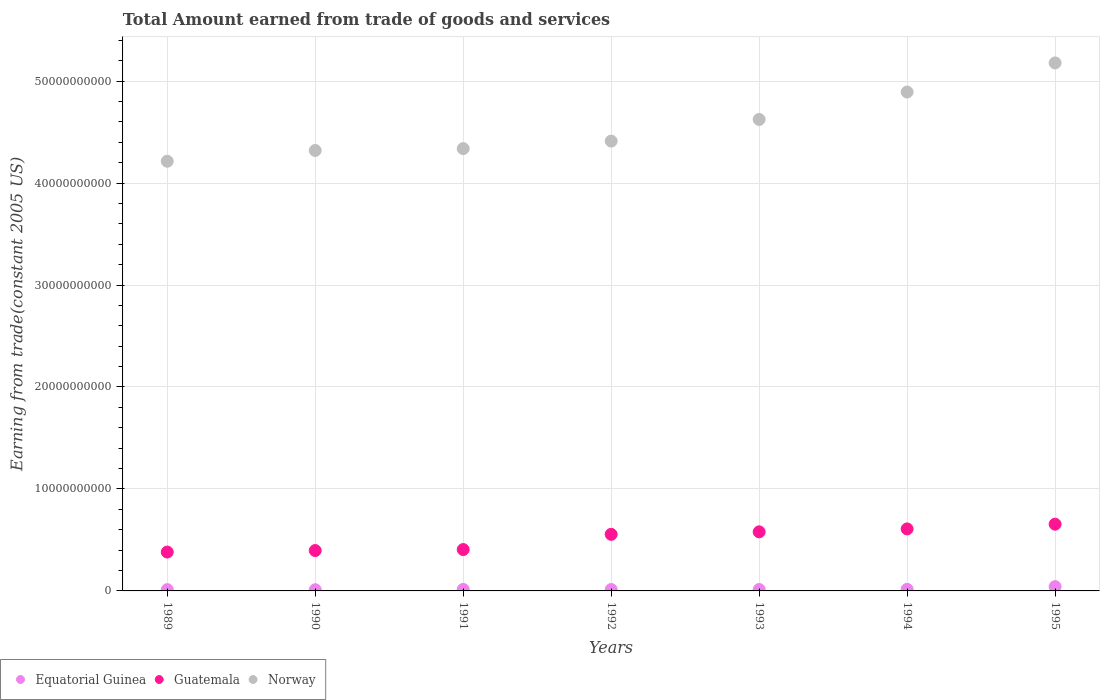What is the total amount earned by trading goods and services in Norway in 1989?
Keep it short and to the point. 4.21e+1. Across all years, what is the maximum total amount earned by trading goods and services in Norway?
Your answer should be very brief. 5.18e+1. Across all years, what is the minimum total amount earned by trading goods and services in Norway?
Keep it short and to the point. 4.21e+1. In which year was the total amount earned by trading goods and services in Equatorial Guinea minimum?
Your answer should be compact. 1990. What is the total total amount earned by trading goods and services in Equatorial Guinea in the graph?
Make the answer very short. 1.23e+09. What is the difference between the total amount earned by trading goods and services in Norway in 1991 and that in 1994?
Offer a terse response. -5.55e+09. What is the difference between the total amount earned by trading goods and services in Guatemala in 1992 and the total amount earned by trading goods and services in Equatorial Guinea in 1994?
Your answer should be very brief. 5.39e+09. What is the average total amount earned by trading goods and services in Norway per year?
Provide a short and direct response. 4.57e+1. In the year 1993, what is the difference between the total amount earned by trading goods and services in Guatemala and total amount earned by trading goods and services in Equatorial Guinea?
Offer a terse response. 5.66e+09. What is the ratio of the total amount earned by trading goods and services in Equatorial Guinea in 1991 to that in 1993?
Provide a short and direct response. 1.08. Is the difference between the total amount earned by trading goods and services in Guatemala in 1989 and 1991 greater than the difference between the total amount earned by trading goods and services in Equatorial Guinea in 1989 and 1991?
Your answer should be very brief. No. What is the difference between the highest and the second highest total amount earned by trading goods and services in Guatemala?
Your answer should be very brief. 4.62e+08. What is the difference between the highest and the lowest total amount earned by trading goods and services in Equatorial Guinea?
Provide a succinct answer. 3.05e+08. Is the sum of the total amount earned by trading goods and services in Norway in 1994 and 1995 greater than the maximum total amount earned by trading goods and services in Guatemala across all years?
Provide a short and direct response. Yes. Does the total amount earned by trading goods and services in Norway monotonically increase over the years?
Give a very brief answer. Yes. What is the difference between two consecutive major ticks on the Y-axis?
Provide a succinct answer. 1.00e+1. Does the graph contain any zero values?
Give a very brief answer. No. Does the graph contain grids?
Give a very brief answer. Yes. How are the legend labels stacked?
Your answer should be compact. Horizontal. What is the title of the graph?
Your answer should be compact. Total Amount earned from trade of goods and services. Does "Central Europe" appear as one of the legend labels in the graph?
Offer a terse response. No. What is the label or title of the Y-axis?
Offer a terse response. Earning from trade(constant 2005 US). What is the Earning from trade(constant 2005 US) of Equatorial Guinea in 1989?
Keep it short and to the point. 1.25e+08. What is the Earning from trade(constant 2005 US) in Guatemala in 1989?
Provide a succinct answer. 3.81e+09. What is the Earning from trade(constant 2005 US) of Norway in 1989?
Offer a very short reply. 4.21e+1. What is the Earning from trade(constant 2005 US) of Equatorial Guinea in 1990?
Give a very brief answer. 1.16e+08. What is the Earning from trade(constant 2005 US) in Guatemala in 1990?
Provide a short and direct response. 3.96e+09. What is the Earning from trade(constant 2005 US) of Norway in 1990?
Offer a terse response. 4.32e+1. What is the Earning from trade(constant 2005 US) in Equatorial Guinea in 1991?
Provide a short and direct response. 1.46e+08. What is the Earning from trade(constant 2005 US) of Guatemala in 1991?
Give a very brief answer. 4.06e+09. What is the Earning from trade(constant 2005 US) of Norway in 1991?
Your answer should be compact. 4.34e+1. What is the Earning from trade(constant 2005 US) of Equatorial Guinea in 1992?
Give a very brief answer. 1.35e+08. What is the Earning from trade(constant 2005 US) in Guatemala in 1992?
Ensure brevity in your answer.  5.55e+09. What is the Earning from trade(constant 2005 US) of Norway in 1992?
Give a very brief answer. 4.41e+1. What is the Earning from trade(constant 2005 US) in Equatorial Guinea in 1993?
Your answer should be compact. 1.35e+08. What is the Earning from trade(constant 2005 US) in Guatemala in 1993?
Provide a short and direct response. 5.79e+09. What is the Earning from trade(constant 2005 US) of Norway in 1993?
Your response must be concise. 4.62e+1. What is the Earning from trade(constant 2005 US) in Equatorial Guinea in 1994?
Keep it short and to the point. 1.54e+08. What is the Earning from trade(constant 2005 US) of Guatemala in 1994?
Ensure brevity in your answer.  6.08e+09. What is the Earning from trade(constant 2005 US) of Norway in 1994?
Your response must be concise. 4.89e+1. What is the Earning from trade(constant 2005 US) of Equatorial Guinea in 1995?
Your response must be concise. 4.21e+08. What is the Earning from trade(constant 2005 US) in Guatemala in 1995?
Your answer should be compact. 6.54e+09. What is the Earning from trade(constant 2005 US) in Norway in 1995?
Your answer should be very brief. 5.18e+1. Across all years, what is the maximum Earning from trade(constant 2005 US) in Equatorial Guinea?
Your answer should be very brief. 4.21e+08. Across all years, what is the maximum Earning from trade(constant 2005 US) in Guatemala?
Provide a short and direct response. 6.54e+09. Across all years, what is the maximum Earning from trade(constant 2005 US) of Norway?
Your response must be concise. 5.18e+1. Across all years, what is the minimum Earning from trade(constant 2005 US) of Equatorial Guinea?
Provide a succinct answer. 1.16e+08. Across all years, what is the minimum Earning from trade(constant 2005 US) in Guatemala?
Your answer should be very brief. 3.81e+09. Across all years, what is the minimum Earning from trade(constant 2005 US) in Norway?
Your answer should be very brief. 4.21e+1. What is the total Earning from trade(constant 2005 US) in Equatorial Guinea in the graph?
Your answer should be very brief. 1.23e+09. What is the total Earning from trade(constant 2005 US) of Guatemala in the graph?
Offer a terse response. 3.58e+1. What is the total Earning from trade(constant 2005 US) of Norway in the graph?
Give a very brief answer. 3.20e+11. What is the difference between the Earning from trade(constant 2005 US) of Equatorial Guinea in 1989 and that in 1990?
Your response must be concise. 9.69e+06. What is the difference between the Earning from trade(constant 2005 US) of Guatemala in 1989 and that in 1990?
Offer a very short reply. -1.48e+08. What is the difference between the Earning from trade(constant 2005 US) in Norway in 1989 and that in 1990?
Provide a short and direct response. -1.06e+09. What is the difference between the Earning from trade(constant 2005 US) of Equatorial Guinea in 1989 and that in 1991?
Your answer should be very brief. -2.10e+07. What is the difference between the Earning from trade(constant 2005 US) in Guatemala in 1989 and that in 1991?
Your response must be concise. -2.46e+08. What is the difference between the Earning from trade(constant 2005 US) of Norway in 1989 and that in 1991?
Keep it short and to the point. -1.24e+09. What is the difference between the Earning from trade(constant 2005 US) of Equatorial Guinea in 1989 and that in 1992?
Provide a succinct answer. -9.87e+06. What is the difference between the Earning from trade(constant 2005 US) in Guatemala in 1989 and that in 1992?
Your answer should be compact. -1.74e+09. What is the difference between the Earning from trade(constant 2005 US) of Norway in 1989 and that in 1992?
Your answer should be compact. -1.98e+09. What is the difference between the Earning from trade(constant 2005 US) of Equatorial Guinea in 1989 and that in 1993?
Your response must be concise. -1.01e+07. What is the difference between the Earning from trade(constant 2005 US) in Guatemala in 1989 and that in 1993?
Offer a very short reply. -1.98e+09. What is the difference between the Earning from trade(constant 2005 US) in Norway in 1989 and that in 1993?
Ensure brevity in your answer.  -4.10e+09. What is the difference between the Earning from trade(constant 2005 US) in Equatorial Guinea in 1989 and that in 1994?
Provide a short and direct response. -2.91e+07. What is the difference between the Earning from trade(constant 2005 US) of Guatemala in 1989 and that in 1994?
Provide a short and direct response. -2.27e+09. What is the difference between the Earning from trade(constant 2005 US) of Norway in 1989 and that in 1994?
Provide a succinct answer. -6.79e+09. What is the difference between the Earning from trade(constant 2005 US) of Equatorial Guinea in 1989 and that in 1995?
Provide a short and direct response. -2.95e+08. What is the difference between the Earning from trade(constant 2005 US) of Guatemala in 1989 and that in 1995?
Your answer should be compact. -2.73e+09. What is the difference between the Earning from trade(constant 2005 US) in Norway in 1989 and that in 1995?
Your answer should be compact. -9.64e+09. What is the difference between the Earning from trade(constant 2005 US) in Equatorial Guinea in 1990 and that in 1991?
Offer a very short reply. -3.07e+07. What is the difference between the Earning from trade(constant 2005 US) of Guatemala in 1990 and that in 1991?
Offer a terse response. -9.72e+07. What is the difference between the Earning from trade(constant 2005 US) of Norway in 1990 and that in 1991?
Give a very brief answer. -1.83e+08. What is the difference between the Earning from trade(constant 2005 US) in Equatorial Guinea in 1990 and that in 1992?
Ensure brevity in your answer.  -1.96e+07. What is the difference between the Earning from trade(constant 2005 US) in Guatemala in 1990 and that in 1992?
Offer a very short reply. -1.59e+09. What is the difference between the Earning from trade(constant 2005 US) in Norway in 1990 and that in 1992?
Your answer should be compact. -9.19e+08. What is the difference between the Earning from trade(constant 2005 US) in Equatorial Guinea in 1990 and that in 1993?
Your answer should be very brief. -1.98e+07. What is the difference between the Earning from trade(constant 2005 US) in Guatemala in 1990 and that in 1993?
Give a very brief answer. -1.83e+09. What is the difference between the Earning from trade(constant 2005 US) in Norway in 1990 and that in 1993?
Provide a succinct answer. -3.04e+09. What is the difference between the Earning from trade(constant 2005 US) of Equatorial Guinea in 1990 and that in 1994?
Offer a terse response. -3.88e+07. What is the difference between the Earning from trade(constant 2005 US) of Guatemala in 1990 and that in 1994?
Provide a succinct answer. -2.12e+09. What is the difference between the Earning from trade(constant 2005 US) in Norway in 1990 and that in 1994?
Your answer should be very brief. -5.73e+09. What is the difference between the Earning from trade(constant 2005 US) of Equatorial Guinea in 1990 and that in 1995?
Your answer should be very brief. -3.05e+08. What is the difference between the Earning from trade(constant 2005 US) of Guatemala in 1990 and that in 1995?
Your answer should be compact. -2.58e+09. What is the difference between the Earning from trade(constant 2005 US) of Norway in 1990 and that in 1995?
Make the answer very short. -8.59e+09. What is the difference between the Earning from trade(constant 2005 US) in Equatorial Guinea in 1991 and that in 1992?
Offer a very short reply. 1.11e+07. What is the difference between the Earning from trade(constant 2005 US) in Guatemala in 1991 and that in 1992?
Make the answer very short. -1.49e+09. What is the difference between the Earning from trade(constant 2005 US) of Norway in 1991 and that in 1992?
Ensure brevity in your answer.  -7.36e+08. What is the difference between the Earning from trade(constant 2005 US) in Equatorial Guinea in 1991 and that in 1993?
Provide a succinct answer. 1.09e+07. What is the difference between the Earning from trade(constant 2005 US) of Guatemala in 1991 and that in 1993?
Offer a very short reply. -1.74e+09. What is the difference between the Earning from trade(constant 2005 US) of Norway in 1991 and that in 1993?
Offer a very short reply. -2.86e+09. What is the difference between the Earning from trade(constant 2005 US) in Equatorial Guinea in 1991 and that in 1994?
Provide a succinct answer. -8.08e+06. What is the difference between the Earning from trade(constant 2005 US) of Guatemala in 1991 and that in 1994?
Give a very brief answer. -2.02e+09. What is the difference between the Earning from trade(constant 2005 US) in Norway in 1991 and that in 1994?
Your answer should be very brief. -5.55e+09. What is the difference between the Earning from trade(constant 2005 US) in Equatorial Guinea in 1991 and that in 1995?
Make the answer very short. -2.74e+08. What is the difference between the Earning from trade(constant 2005 US) of Guatemala in 1991 and that in 1995?
Your answer should be very brief. -2.49e+09. What is the difference between the Earning from trade(constant 2005 US) in Norway in 1991 and that in 1995?
Give a very brief answer. -8.40e+09. What is the difference between the Earning from trade(constant 2005 US) in Equatorial Guinea in 1992 and that in 1993?
Your response must be concise. -2.36e+05. What is the difference between the Earning from trade(constant 2005 US) of Guatemala in 1992 and that in 1993?
Give a very brief answer. -2.45e+08. What is the difference between the Earning from trade(constant 2005 US) of Norway in 1992 and that in 1993?
Your response must be concise. -2.13e+09. What is the difference between the Earning from trade(constant 2005 US) in Equatorial Guinea in 1992 and that in 1994?
Keep it short and to the point. -1.92e+07. What is the difference between the Earning from trade(constant 2005 US) in Guatemala in 1992 and that in 1994?
Ensure brevity in your answer.  -5.33e+08. What is the difference between the Earning from trade(constant 2005 US) of Norway in 1992 and that in 1994?
Make the answer very short. -4.81e+09. What is the difference between the Earning from trade(constant 2005 US) of Equatorial Guinea in 1992 and that in 1995?
Provide a short and direct response. -2.85e+08. What is the difference between the Earning from trade(constant 2005 US) of Guatemala in 1992 and that in 1995?
Give a very brief answer. -9.95e+08. What is the difference between the Earning from trade(constant 2005 US) in Norway in 1992 and that in 1995?
Your answer should be compact. -7.67e+09. What is the difference between the Earning from trade(constant 2005 US) of Equatorial Guinea in 1993 and that in 1994?
Your response must be concise. -1.90e+07. What is the difference between the Earning from trade(constant 2005 US) in Guatemala in 1993 and that in 1994?
Offer a terse response. -2.87e+08. What is the difference between the Earning from trade(constant 2005 US) in Norway in 1993 and that in 1994?
Your answer should be very brief. -2.69e+09. What is the difference between the Earning from trade(constant 2005 US) of Equatorial Guinea in 1993 and that in 1995?
Offer a terse response. -2.85e+08. What is the difference between the Earning from trade(constant 2005 US) of Guatemala in 1993 and that in 1995?
Your answer should be very brief. -7.49e+08. What is the difference between the Earning from trade(constant 2005 US) of Norway in 1993 and that in 1995?
Give a very brief answer. -5.54e+09. What is the difference between the Earning from trade(constant 2005 US) of Equatorial Guinea in 1994 and that in 1995?
Offer a terse response. -2.66e+08. What is the difference between the Earning from trade(constant 2005 US) in Guatemala in 1994 and that in 1995?
Your answer should be very brief. -4.62e+08. What is the difference between the Earning from trade(constant 2005 US) in Norway in 1994 and that in 1995?
Give a very brief answer. -2.85e+09. What is the difference between the Earning from trade(constant 2005 US) of Equatorial Guinea in 1989 and the Earning from trade(constant 2005 US) of Guatemala in 1990?
Offer a very short reply. -3.83e+09. What is the difference between the Earning from trade(constant 2005 US) of Equatorial Guinea in 1989 and the Earning from trade(constant 2005 US) of Norway in 1990?
Your response must be concise. -4.31e+1. What is the difference between the Earning from trade(constant 2005 US) of Guatemala in 1989 and the Earning from trade(constant 2005 US) of Norway in 1990?
Keep it short and to the point. -3.94e+1. What is the difference between the Earning from trade(constant 2005 US) in Equatorial Guinea in 1989 and the Earning from trade(constant 2005 US) in Guatemala in 1991?
Offer a very short reply. -3.93e+09. What is the difference between the Earning from trade(constant 2005 US) in Equatorial Guinea in 1989 and the Earning from trade(constant 2005 US) in Norway in 1991?
Keep it short and to the point. -4.33e+1. What is the difference between the Earning from trade(constant 2005 US) in Guatemala in 1989 and the Earning from trade(constant 2005 US) in Norway in 1991?
Your response must be concise. -3.96e+1. What is the difference between the Earning from trade(constant 2005 US) of Equatorial Guinea in 1989 and the Earning from trade(constant 2005 US) of Guatemala in 1992?
Offer a very short reply. -5.42e+09. What is the difference between the Earning from trade(constant 2005 US) of Equatorial Guinea in 1989 and the Earning from trade(constant 2005 US) of Norway in 1992?
Keep it short and to the point. -4.40e+1. What is the difference between the Earning from trade(constant 2005 US) in Guatemala in 1989 and the Earning from trade(constant 2005 US) in Norway in 1992?
Ensure brevity in your answer.  -4.03e+1. What is the difference between the Earning from trade(constant 2005 US) of Equatorial Guinea in 1989 and the Earning from trade(constant 2005 US) of Guatemala in 1993?
Give a very brief answer. -5.67e+09. What is the difference between the Earning from trade(constant 2005 US) in Equatorial Guinea in 1989 and the Earning from trade(constant 2005 US) in Norway in 1993?
Ensure brevity in your answer.  -4.61e+1. What is the difference between the Earning from trade(constant 2005 US) of Guatemala in 1989 and the Earning from trade(constant 2005 US) of Norway in 1993?
Provide a succinct answer. -4.24e+1. What is the difference between the Earning from trade(constant 2005 US) of Equatorial Guinea in 1989 and the Earning from trade(constant 2005 US) of Guatemala in 1994?
Make the answer very short. -5.96e+09. What is the difference between the Earning from trade(constant 2005 US) in Equatorial Guinea in 1989 and the Earning from trade(constant 2005 US) in Norway in 1994?
Provide a succinct answer. -4.88e+1. What is the difference between the Earning from trade(constant 2005 US) in Guatemala in 1989 and the Earning from trade(constant 2005 US) in Norway in 1994?
Your answer should be compact. -4.51e+1. What is the difference between the Earning from trade(constant 2005 US) in Equatorial Guinea in 1989 and the Earning from trade(constant 2005 US) in Guatemala in 1995?
Keep it short and to the point. -6.42e+09. What is the difference between the Earning from trade(constant 2005 US) of Equatorial Guinea in 1989 and the Earning from trade(constant 2005 US) of Norway in 1995?
Provide a succinct answer. -5.17e+1. What is the difference between the Earning from trade(constant 2005 US) in Guatemala in 1989 and the Earning from trade(constant 2005 US) in Norway in 1995?
Offer a very short reply. -4.80e+1. What is the difference between the Earning from trade(constant 2005 US) in Equatorial Guinea in 1990 and the Earning from trade(constant 2005 US) in Guatemala in 1991?
Your answer should be very brief. -3.94e+09. What is the difference between the Earning from trade(constant 2005 US) of Equatorial Guinea in 1990 and the Earning from trade(constant 2005 US) of Norway in 1991?
Your response must be concise. -4.33e+1. What is the difference between the Earning from trade(constant 2005 US) of Guatemala in 1990 and the Earning from trade(constant 2005 US) of Norway in 1991?
Provide a succinct answer. -3.94e+1. What is the difference between the Earning from trade(constant 2005 US) in Equatorial Guinea in 1990 and the Earning from trade(constant 2005 US) in Guatemala in 1992?
Your answer should be very brief. -5.43e+09. What is the difference between the Earning from trade(constant 2005 US) of Equatorial Guinea in 1990 and the Earning from trade(constant 2005 US) of Norway in 1992?
Ensure brevity in your answer.  -4.40e+1. What is the difference between the Earning from trade(constant 2005 US) in Guatemala in 1990 and the Earning from trade(constant 2005 US) in Norway in 1992?
Your answer should be compact. -4.02e+1. What is the difference between the Earning from trade(constant 2005 US) of Equatorial Guinea in 1990 and the Earning from trade(constant 2005 US) of Guatemala in 1993?
Your answer should be compact. -5.68e+09. What is the difference between the Earning from trade(constant 2005 US) of Equatorial Guinea in 1990 and the Earning from trade(constant 2005 US) of Norway in 1993?
Provide a succinct answer. -4.61e+1. What is the difference between the Earning from trade(constant 2005 US) in Guatemala in 1990 and the Earning from trade(constant 2005 US) in Norway in 1993?
Provide a succinct answer. -4.23e+1. What is the difference between the Earning from trade(constant 2005 US) in Equatorial Guinea in 1990 and the Earning from trade(constant 2005 US) in Guatemala in 1994?
Offer a very short reply. -5.97e+09. What is the difference between the Earning from trade(constant 2005 US) in Equatorial Guinea in 1990 and the Earning from trade(constant 2005 US) in Norway in 1994?
Offer a very short reply. -4.88e+1. What is the difference between the Earning from trade(constant 2005 US) in Guatemala in 1990 and the Earning from trade(constant 2005 US) in Norway in 1994?
Give a very brief answer. -4.50e+1. What is the difference between the Earning from trade(constant 2005 US) in Equatorial Guinea in 1990 and the Earning from trade(constant 2005 US) in Guatemala in 1995?
Ensure brevity in your answer.  -6.43e+09. What is the difference between the Earning from trade(constant 2005 US) in Equatorial Guinea in 1990 and the Earning from trade(constant 2005 US) in Norway in 1995?
Give a very brief answer. -5.17e+1. What is the difference between the Earning from trade(constant 2005 US) in Guatemala in 1990 and the Earning from trade(constant 2005 US) in Norway in 1995?
Ensure brevity in your answer.  -4.78e+1. What is the difference between the Earning from trade(constant 2005 US) in Equatorial Guinea in 1991 and the Earning from trade(constant 2005 US) in Guatemala in 1992?
Keep it short and to the point. -5.40e+09. What is the difference between the Earning from trade(constant 2005 US) of Equatorial Guinea in 1991 and the Earning from trade(constant 2005 US) of Norway in 1992?
Make the answer very short. -4.40e+1. What is the difference between the Earning from trade(constant 2005 US) of Guatemala in 1991 and the Earning from trade(constant 2005 US) of Norway in 1992?
Your answer should be very brief. -4.01e+1. What is the difference between the Earning from trade(constant 2005 US) of Equatorial Guinea in 1991 and the Earning from trade(constant 2005 US) of Guatemala in 1993?
Give a very brief answer. -5.65e+09. What is the difference between the Earning from trade(constant 2005 US) of Equatorial Guinea in 1991 and the Earning from trade(constant 2005 US) of Norway in 1993?
Keep it short and to the point. -4.61e+1. What is the difference between the Earning from trade(constant 2005 US) in Guatemala in 1991 and the Earning from trade(constant 2005 US) in Norway in 1993?
Offer a terse response. -4.22e+1. What is the difference between the Earning from trade(constant 2005 US) in Equatorial Guinea in 1991 and the Earning from trade(constant 2005 US) in Guatemala in 1994?
Your answer should be compact. -5.94e+09. What is the difference between the Earning from trade(constant 2005 US) of Equatorial Guinea in 1991 and the Earning from trade(constant 2005 US) of Norway in 1994?
Provide a short and direct response. -4.88e+1. What is the difference between the Earning from trade(constant 2005 US) in Guatemala in 1991 and the Earning from trade(constant 2005 US) in Norway in 1994?
Provide a short and direct response. -4.49e+1. What is the difference between the Earning from trade(constant 2005 US) of Equatorial Guinea in 1991 and the Earning from trade(constant 2005 US) of Guatemala in 1995?
Your answer should be compact. -6.40e+09. What is the difference between the Earning from trade(constant 2005 US) of Equatorial Guinea in 1991 and the Earning from trade(constant 2005 US) of Norway in 1995?
Your answer should be very brief. -5.16e+1. What is the difference between the Earning from trade(constant 2005 US) in Guatemala in 1991 and the Earning from trade(constant 2005 US) in Norway in 1995?
Give a very brief answer. -4.77e+1. What is the difference between the Earning from trade(constant 2005 US) in Equatorial Guinea in 1992 and the Earning from trade(constant 2005 US) in Guatemala in 1993?
Make the answer very short. -5.66e+09. What is the difference between the Earning from trade(constant 2005 US) of Equatorial Guinea in 1992 and the Earning from trade(constant 2005 US) of Norway in 1993?
Provide a short and direct response. -4.61e+1. What is the difference between the Earning from trade(constant 2005 US) in Guatemala in 1992 and the Earning from trade(constant 2005 US) in Norway in 1993?
Offer a very short reply. -4.07e+1. What is the difference between the Earning from trade(constant 2005 US) in Equatorial Guinea in 1992 and the Earning from trade(constant 2005 US) in Guatemala in 1994?
Keep it short and to the point. -5.95e+09. What is the difference between the Earning from trade(constant 2005 US) of Equatorial Guinea in 1992 and the Earning from trade(constant 2005 US) of Norway in 1994?
Offer a very short reply. -4.88e+1. What is the difference between the Earning from trade(constant 2005 US) in Guatemala in 1992 and the Earning from trade(constant 2005 US) in Norway in 1994?
Keep it short and to the point. -4.34e+1. What is the difference between the Earning from trade(constant 2005 US) in Equatorial Guinea in 1992 and the Earning from trade(constant 2005 US) in Guatemala in 1995?
Offer a very short reply. -6.41e+09. What is the difference between the Earning from trade(constant 2005 US) in Equatorial Guinea in 1992 and the Earning from trade(constant 2005 US) in Norway in 1995?
Give a very brief answer. -5.16e+1. What is the difference between the Earning from trade(constant 2005 US) in Guatemala in 1992 and the Earning from trade(constant 2005 US) in Norway in 1995?
Offer a terse response. -4.62e+1. What is the difference between the Earning from trade(constant 2005 US) in Equatorial Guinea in 1993 and the Earning from trade(constant 2005 US) in Guatemala in 1994?
Offer a very short reply. -5.95e+09. What is the difference between the Earning from trade(constant 2005 US) in Equatorial Guinea in 1993 and the Earning from trade(constant 2005 US) in Norway in 1994?
Provide a short and direct response. -4.88e+1. What is the difference between the Earning from trade(constant 2005 US) in Guatemala in 1993 and the Earning from trade(constant 2005 US) in Norway in 1994?
Provide a succinct answer. -4.31e+1. What is the difference between the Earning from trade(constant 2005 US) in Equatorial Guinea in 1993 and the Earning from trade(constant 2005 US) in Guatemala in 1995?
Your response must be concise. -6.41e+09. What is the difference between the Earning from trade(constant 2005 US) of Equatorial Guinea in 1993 and the Earning from trade(constant 2005 US) of Norway in 1995?
Provide a short and direct response. -5.16e+1. What is the difference between the Earning from trade(constant 2005 US) in Guatemala in 1993 and the Earning from trade(constant 2005 US) in Norway in 1995?
Keep it short and to the point. -4.60e+1. What is the difference between the Earning from trade(constant 2005 US) in Equatorial Guinea in 1994 and the Earning from trade(constant 2005 US) in Guatemala in 1995?
Keep it short and to the point. -6.39e+09. What is the difference between the Earning from trade(constant 2005 US) in Equatorial Guinea in 1994 and the Earning from trade(constant 2005 US) in Norway in 1995?
Keep it short and to the point. -5.16e+1. What is the difference between the Earning from trade(constant 2005 US) in Guatemala in 1994 and the Earning from trade(constant 2005 US) in Norway in 1995?
Your answer should be very brief. -4.57e+1. What is the average Earning from trade(constant 2005 US) in Equatorial Guinea per year?
Ensure brevity in your answer.  1.76e+08. What is the average Earning from trade(constant 2005 US) of Guatemala per year?
Make the answer very short. 5.11e+09. What is the average Earning from trade(constant 2005 US) of Norway per year?
Make the answer very short. 4.57e+1. In the year 1989, what is the difference between the Earning from trade(constant 2005 US) of Equatorial Guinea and Earning from trade(constant 2005 US) of Guatemala?
Offer a terse response. -3.69e+09. In the year 1989, what is the difference between the Earning from trade(constant 2005 US) of Equatorial Guinea and Earning from trade(constant 2005 US) of Norway?
Offer a terse response. -4.20e+1. In the year 1989, what is the difference between the Earning from trade(constant 2005 US) in Guatemala and Earning from trade(constant 2005 US) in Norway?
Offer a very short reply. -3.83e+1. In the year 1990, what is the difference between the Earning from trade(constant 2005 US) in Equatorial Guinea and Earning from trade(constant 2005 US) in Guatemala?
Your response must be concise. -3.84e+09. In the year 1990, what is the difference between the Earning from trade(constant 2005 US) in Equatorial Guinea and Earning from trade(constant 2005 US) in Norway?
Provide a succinct answer. -4.31e+1. In the year 1990, what is the difference between the Earning from trade(constant 2005 US) in Guatemala and Earning from trade(constant 2005 US) in Norway?
Provide a short and direct response. -3.92e+1. In the year 1991, what is the difference between the Earning from trade(constant 2005 US) of Equatorial Guinea and Earning from trade(constant 2005 US) of Guatemala?
Your answer should be very brief. -3.91e+09. In the year 1991, what is the difference between the Earning from trade(constant 2005 US) of Equatorial Guinea and Earning from trade(constant 2005 US) of Norway?
Provide a short and direct response. -4.32e+1. In the year 1991, what is the difference between the Earning from trade(constant 2005 US) in Guatemala and Earning from trade(constant 2005 US) in Norway?
Give a very brief answer. -3.93e+1. In the year 1992, what is the difference between the Earning from trade(constant 2005 US) in Equatorial Guinea and Earning from trade(constant 2005 US) in Guatemala?
Offer a terse response. -5.41e+09. In the year 1992, what is the difference between the Earning from trade(constant 2005 US) of Equatorial Guinea and Earning from trade(constant 2005 US) of Norway?
Provide a short and direct response. -4.40e+1. In the year 1992, what is the difference between the Earning from trade(constant 2005 US) in Guatemala and Earning from trade(constant 2005 US) in Norway?
Make the answer very short. -3.86e+1. In the year 1993, what is the difference between the Earning from trade(constant 2005 US) in Equatorial Guinea and Earning from trade(constant 2005 US) in Guatemala?
Provide a short and direct response. -5.66e+09. In the year 1993, what is the difference between the Earning from trade(constant 2005 US) in Equatorial Guinea and Earning from trade(constant 2005 US) in Norway?
Provide a short and direct response. -4.61e+1. In the year 1993, what is the difference between the Earning from trade(constant 2005 US) in Guatemala and Earning from trade(constant 2005 US) in Norway?
Provide a succinct answer. -4.04e+1. In the year 1994, what is the difference between the Earning from trade(constant 2005 US) of Equatorial Guinea and Earning from trade(constant 2005 US) of Guatemala?
Provide a succinct answer. -5.93e+09. In the year 1994, what is the difference between the Earning from trade(constant 2005 US) of Equatorial Guinea and Earning from trade(constant 2005 US) of Norway?
Your answer should be compact. -4.88e+1. In the year 1994, what is the difference between the Earning from trade(constant 2005 US) in Guatemala and Earning from trade(constant 2005 US) in Norway?
Ensure brevity in your answer.  -4.28e+1. In the year 1995, what is the difference between the Earning from trade(constant 2005 US) in Equatorial Guinea and Earning from trade(constant 2005 US) in Guatemala?
Make the answer very short. -6.12e+09. In the year 1995, what is the difference between the Earning from trade(constant 2005 US) of Equatorial Guinea and Earning from trade(constant 2005 US) of Norway?
Offer a terse response. -5.14e+1. In the year 1995, what is the difference between the Earning from trade(constant 2005 US) of Guatemala and Earning from trade(constant 2005 US) of Norway?
Your answer should be very brief. -4.52e+1. What is the ratio of the Earning from trade(constant 2005 US) of Equatorial Guinea in 1989 to that in 1990?
Your response must be concise. 1.08. What is the ratio of the Earning from trade(constant 2005 US) of Guatemala in 1989 to that in 1990?
Your answer should be very brief. 0.96. What is the ratio of the Earning from trade(constant 2005 US) of Norway in 1989 to that in 1990?
Keep it short and to the point. 0.98. What is the ratio of the Earning from trade(constant 2005 US) of Equatorial Guinea in 1989 to that in 1991?
Make the answer very short. 0.86. What is the ratio of the Earning from trade(constant 2005 US) in Guatemala in 1989 to that in 1991?
Keep it short and to the point. 0.94. What is the ratio of the Earning from trade(constant 2005 US) of Norway in 1989 to that in 1991?
Provide a succinct answer. 0.97. What is the ratio of the Earning from trade(constant 2005 US) in Equatorial Guinea in 1989 to that in 1992?
Give a very brief answer. 0.93. What is the ratio of the Earning from trade(constant 2005 US) of Guatemala in 1989 to that in 1992?
Keep it short and to the point. 0.69. What is the ratio of the Earning from trade(constant 2005 US) of Norway in 1989 to that in 1992?
Provide a succinct answer. 0.96. What is the ratio of the Earning from trade(constant 2005 US) in Equatorial Guinea in 1989 to that in 1993?
Provide a short and direct response. 0.93. What is the ratio of the Earning from trade(constant 2005 US) in Guatemala in 1989 to that in 1993?
Give a very brief answer. 0.66. What is the ratio of the Earning from trade(constant 2005 US) in Norway in 1989 to that in 1993?
Give a very brief answer. 0.91. What is the ratio of the Earning from trade(constant 2005 US) of Equatorial Guinea in 1989 to that in 1994?
Make the answer very short. 0.81. What is the ratio of the Earning from trade(constant 2005 US) in Guatemala in 1989 to that in 1994?
Provide a succinct answer. 0.63. What is the ratio of the Earning from trade(constant 2005 US) of Norway in 1989 to that in 1994?
Give a very brief answer. 0.86. What is the ratio of the Earning from trade(constant 2005 US) of Equatorial Guinea in 1989 to that in 1995?
Your answer should be compact. 0.3. What is the ratio of the Earning from trade(constant 2005 US) in Guatemala in 1989 to that in 1995?
Your answer should be compact. 0.58. What is the ratio of the Earning from trade(constant 2005 US) of Norway in 1989 to that in 1995?
Your answer should be very brief. 0.81. What is the ratio of the Earning from trade(constant 2005 US) of Equatorial Guinea in 1990 to that in 1991?
Give a very brief answer. 0.79. What is the ratio of the Earning from trade(constant 2005 US) of Norway in 1990 to that in 1991?
Your answer should be very brief. 1. What is the ratio of the Earning from trade(constant 2005 US) of Equatorial Guinea in 1990 to that in 1992?
Keep it short and to the point. 0.86. What is the ratio of the Earning from trade(constant 2005 US) in Guatemala in 1990 to that in 1992?
Your answer should be compact. 0.71. What is the ratio of the Earning from trade(constant 2005 US) of Norway in 1990 to that in 1992?
Your response must be concise. 0.98. What is the ratio of the Earning from trade(constant 2005 US) of Equatorial Guinea in 1990 to that in 1993?
Your answer should be compact. 0.85. What is the ratio of the Earning from trade(constant 2005 US) of Guatemala in 1990 to that in 1993?
Give a very brief answer. 0.68. What is the ratio of the Earning from trade(constant 2005 US) in Norway in 1990 to that in 1993?
Offer a terse response. 0.93. What is the ratio of the Earning from trade(constant 2005 US) of Equatorial Guinea in 1990 to that in 1994?
Your answer should be compact. 0.75. What is the ratio of the Earning from trade(constant 2005 US) of Guatemala in 1990 to that in 1994?
Your response must be concise. 0.65. What is the ratio of the Earning from trade(constant 2005 US) of Norway in 1990 to that in 1994?
Make the answer very short. 0.88. What is the ratio of the Earning from trade(constant 2005 US) in Equatorial Guinea in 1990 to that in 1995?
Give a very brief answer. 0.27. What is the ratio of the Earning from trade(constant 2005 US) of Guatemala in 1990 to that in 1995?
Offer a very short reply. 0.61. What is the ratio of the Earning from trade(constant 2005 US) in Norway in 1990 to that in 1995?
Give a very brief answer. 0.83. What is the ratio of the Earning from trade(constant 2005 US) in Equatorial Guinea in 1991 to that in 1992?
Your answer should be very brief. 1.08. What is the ratio of the Earning from trade(constant 2005 US) of Guatemala in 1991 to that in 1992?
Provide a short and direct response. 0.73. What is the ratio of the Earning from trade(constant 2005 US) of Norway in 1991 to that in 1992?
Your answer should be compact. 0.98. What is the ratio of the Earning from trade(constant 2005 US) in Equatorial Guinea in 1991 to that in 1993?
Provide a succinct answer. 1.08. What is the ratio of the Earning from trade(constant 2005 US) of Guatemala in 1991 to that in 1993?
Your response must be concise. 0.7. What is the ratio of the Earning from trade(constant 2005 US) in Norway in 1991 to that in 1993?
Provide a short and direct response. 0.94. What is the ratio of the Earning from trade(constant 2005 US) of Equatorial Guinea in 1991 to that in 1994?
Offer a terse response. 0.95. What is the ratio of the Earning from trade(constant 2005 US) in Guatemala in 1991 to that in 1994?
Offer a terse response. 0.67. What is the ratio of the Earning from trade(constant 2005 US) in Norway in 1991 to that in 1994?
Your response must be concise. 0.89. What is the ratio of the Earning from trade(constant 2005 US) in Equatorial Guinea in 1991 to that in 1995?
Give a very brief answer. 0.35. What is the ratio of the Earning from trade(constant 2005 US) of Guatemala in 1991 to that in 1995?
Give a very brief answer. 0.62. What is the ratio of the Earning from trade(constant 2005 US) of Norway in 1991 to that in 1995?
Provide a succinct answer. 0.84. What is the ratio of the Earning from trade(constant 2005 US) in Equatorial Guinea in 1992 to that in 1993?
Keep it short and to the point. 1. What is the ratio of the Earning from trade(constant 2005 US) in Guatemala in 1992 to that in 1993?
Provide a short and direct response. 0.96. What is the ratio of the Earning from trade(constant 2005 US) of Norway in 1992 to that in 1993?
Keep it short and to the point. 0.95. What is the ratio of the Earning from trade(constant 2005 US) of Equatorial Guinea in 1992 to that in 1994?
Make the answer very short. 0.88. What is the ratio of the Earning from trade(constant 2005 US) in Guatemala in 1992 to that in 1994?
Offer a terse response. 0.91. What is the ratio of the Earning from trade(constant 2005 US) of Norway in 1992 to that in 1994?
Ensure brevity in your answer.  0.9. What is the ratio of the Earning from trade(constant 2005 US) of Equatorial Guinea in 1992 to that in 1995?
Offer a terse response. 0.32. What is the ratio of the Earning from trade(constant 2005 US) in Guatemala in 1992 to that in 1995?
Your answer should be compact. 0.85. What is the ratio of the Earning from trade(constant 2005 US) of Norway in 1992 to that in 1995?
Provide a succinct answer. 0.85. What is the ratio of the Earning from trade(constant 2005 US) in Equatorial Guinea in 1993 to that in 1994?
Your answer should be very brief. 0.88. What is the ratio of the Earning from trade(constant 2005 US) in Guatemala in 1993 to that in 1994?
Ensure brevity in your answer.  0.95. What is the ratio of the Earning from trade(constant 2005 US) in Norway in 1993 to that in 1994?
Offer a very short reply. 0.94. What is the ratio of the Earning from trade(constant 2005 US) in Equatorial Guinea in 1993 to that in 1995?
Provide a short and direct response. 0.32. What is the ratio of the Earning from trade(constant 2005 US) of Guatemala in 1993 to that in 1995?
Provide a succinct answer. 0.89. What is the ratio of the Earning from trade(constant 2005 US) of Norway in 1993 to that in 1995?
Keep it short and to the point. 0.89. What is the ratio of the Earning from trade(constant 2005 US) of Equatorial Guinea in 1994 to that in 1995?
Your answer should be very brief. 0.37. What is the ratio of the Earning from trade(constant 2005 US) in Guatemala in 1994 to that in 1995?
Offer a very short reply. 0.93. What is the ratio of the Earning from trade(constant 2005 US) of Norway in 1994 to that in 1995?
Keep it short and to the point. 0.94. What is the difference between the highest and the second highest Earning from trade(constant 2005 US) in Equatorial Guinea?
Give a very brief answer. 2.66e+08. What is the difference between the highest and the second highest Earning from trade(constant 2005 US) of Guatemala?
Ensure brevity in your answer.  4.62e+08. What is the difference between the highest and the second highest Earning from trade(constant 2005 US) in Norway?
Offer a terse response. 2.85e+09. What is the difference between the highest and the lowest Earning from trade(constant 2005 US) of Equatorial Guinea?
Provide a short and direct response. 3.05e+08. What is the difference between the highest and the lowest Earning from trade(constant 2005 US) of Guatemala?
Keep it short and to the point. 2.73e+09. What is the difference between the highest and the lowest Earning from trade(constant 2005 US) in Norway?
Your answer should be very brief. 9.64e+09. 